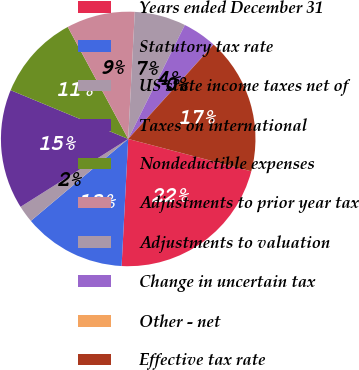Convert chart to OTSL. <chart><loc_0><loc_0><loc_500><loc_500><pie_chart><fcel>Years ended December 31<fcel>Statutory tax rate<fcel>US state income taxes net of<fcel>Taxes on international<fcel>Nondeductible expenses<fcel>Adjustments to prior year tax<fcel>Adjustments to valuation<fcel>Change in uncertain tax<fcel>Other - net<fcel>Effective tax rate<nl><fcel>21.73%<fcel>13.04%<fcel>2.18%<fcel>15.21%<fcel>10.87%<fcel>8.7%<fcel>6.52%<fcel>4.35%<fcel>0.01%<fcel>17.39%<nl></chart> 